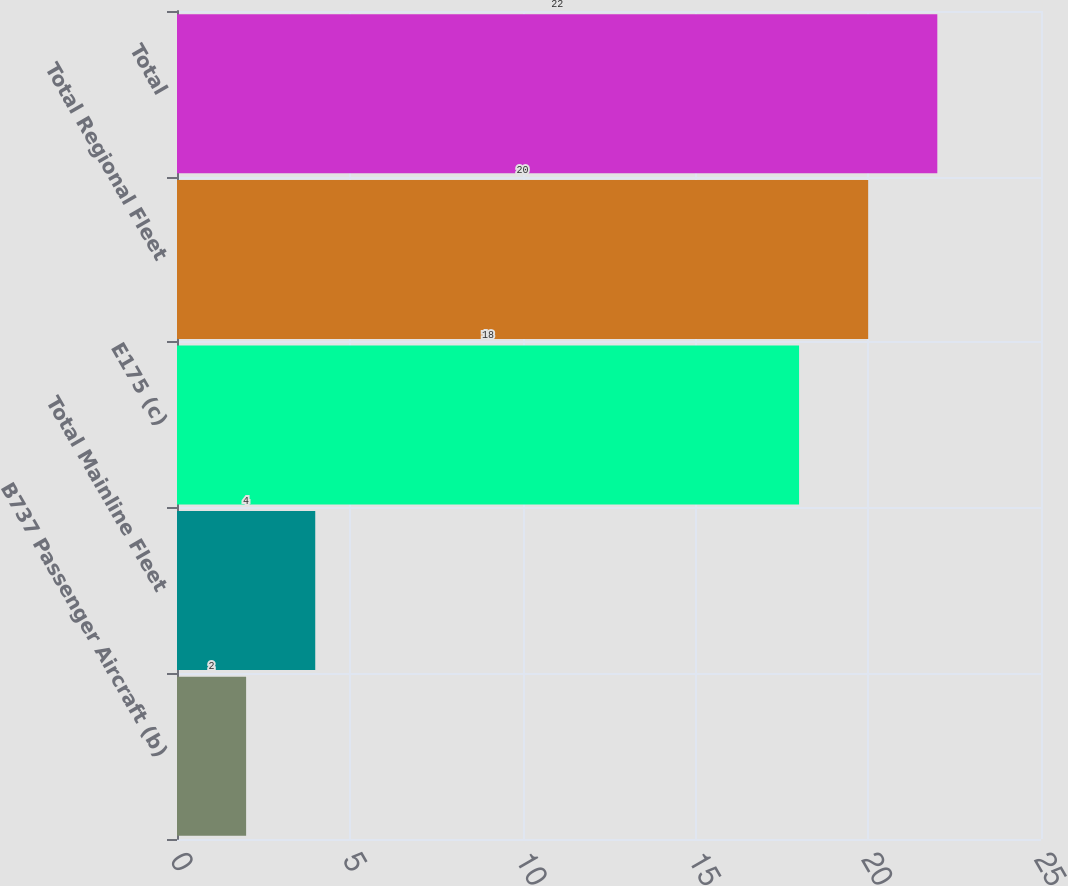<chart> <loc_0><loc_0><loc_500><loc_500><bar_chart><fcel>B737 Passenger Aircraft (b)<fcel>Total Mainline Fleet<fcel>E175 (c)<fcel>Total Regional Fleet<fcel>Total<nl><fcel>2<fcel>4<fcel>18<fcel>20<fcel>22<nl></chart> 